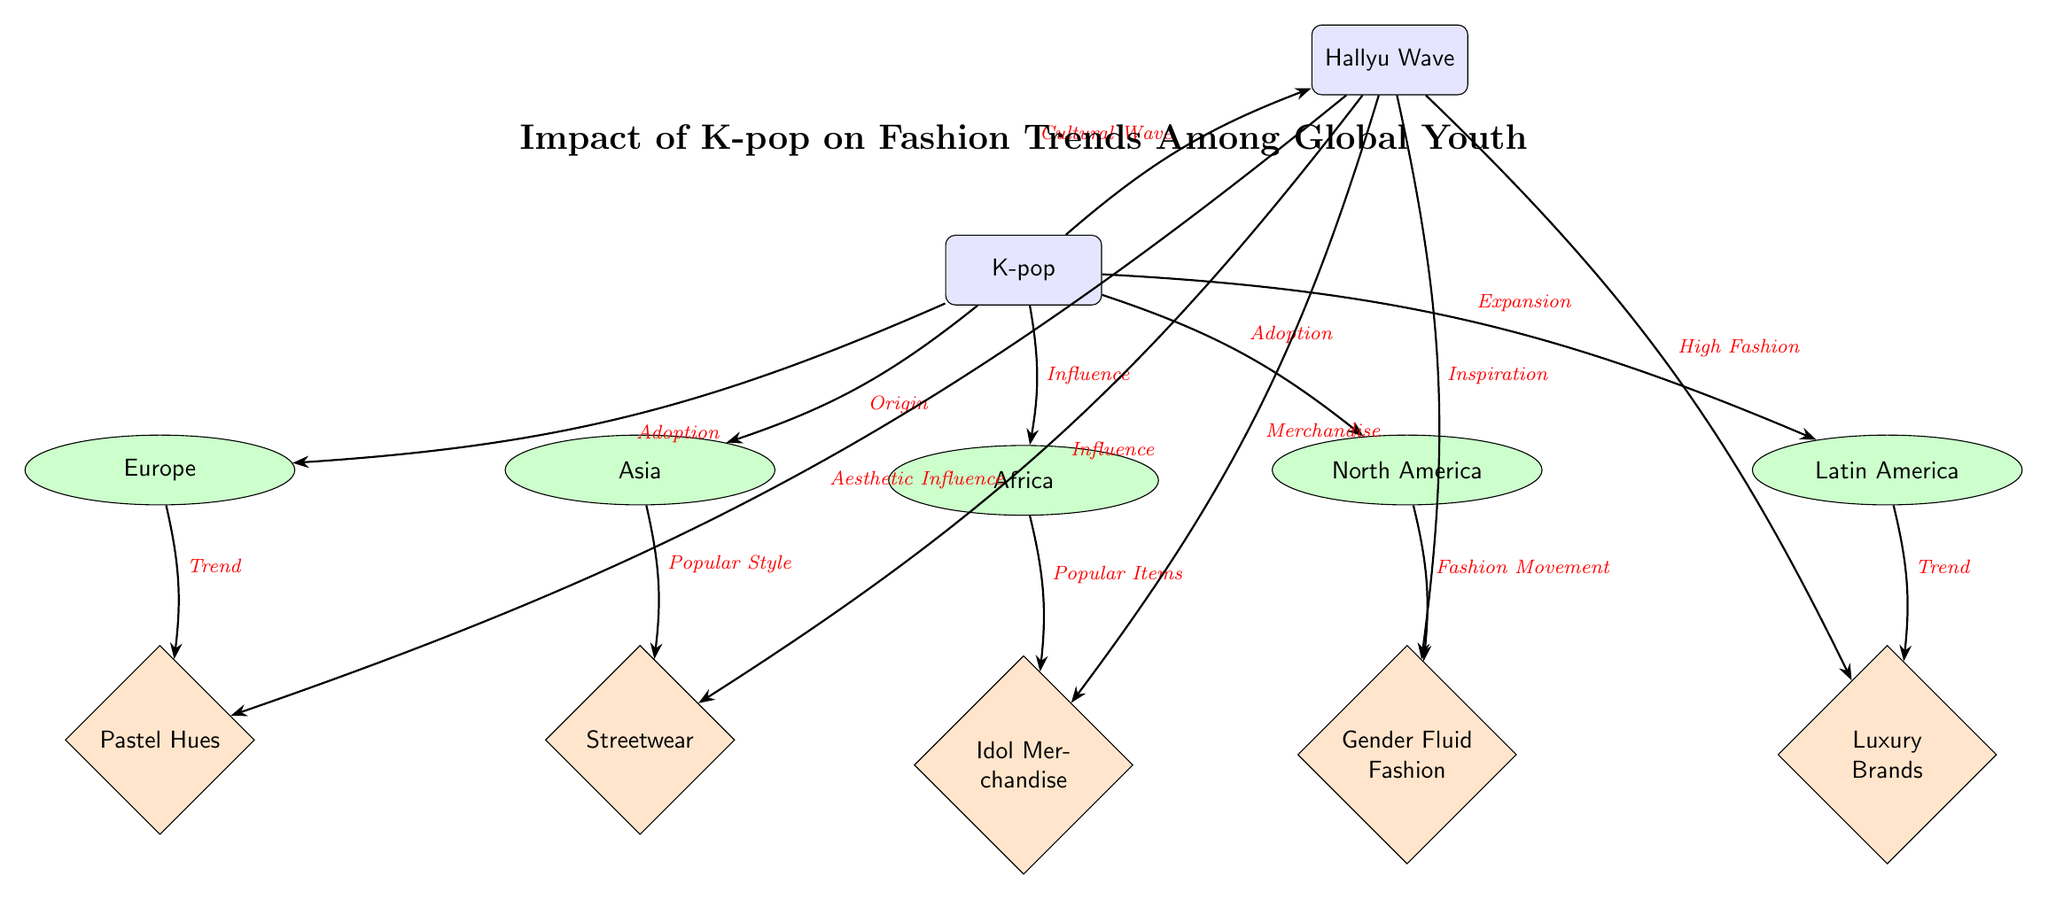What is the origin of K-pop according to the diagram? The diagram indicates that K-pop originates from Asia, as shown by the edge labeled "Origin" pointing from K-pop to Asia.
Answer: Asia What trend is associated with Europe in the context of K-pop fashion influence? The diagram links Europe to the trend labeled "Pastel Hues" through the edge marked "Trend" connecting Europe to Pastel Hues.
Answer: Pastel Hues How many continents are depicted in the diagram? By counting the nodes labeled as continents, we can see there are five: Asia, Europe, North America, Latin America, and Africa.
Answer: Five Which continent shows "Idol Merchandise" as a popular item influenced by K-pop? The diagram shows that Africa is connected to "Idol Merchandise" with the edge labeled "Popular Items", indicating this relationship.
Answer: Africa What type of fashion movement is represented in North America due to K-pop? The diagram indicates that North America is associated with "Gender Fluid Fashion", shown by the edge labeled "Fashion Movement" pointing to this trend.
Answer: Gender Fluid Fashion How does K-pop influence luxury fashion brands according to the diagram? K-pop is linked to Latin America, indicating an "Expansion" from K-pop leading to the trend of "Luxury Brands", shown by an edge labeled "Trend".
Answer: Luxury Brands Which K-pop inspired trend is influenced by the Hallyu Wave? The diagram shows multiple arrows pointing from the Hallyu Wave, and "Gender Fluid Fashion" is specifically labeled as "Inspiration", demonstrating this influence.
Answer: Gender Fluid Fashion What is the relationship between K-pop and the Hallyu Wave in the diagram? The diagram illustrates a direct relationship where K-pop leads to the Hallyu Wave as shown by the edge labeled "Cultural Wave" connecting these two concepts.
Answer: Cultural Wave Which trend is indicated as a popular style directly linked to Asia? The diagram states that "Streetwear" is the popular style associated with Asia, connected by the edge labeled "Popular Style".
Answer: Streetwear 